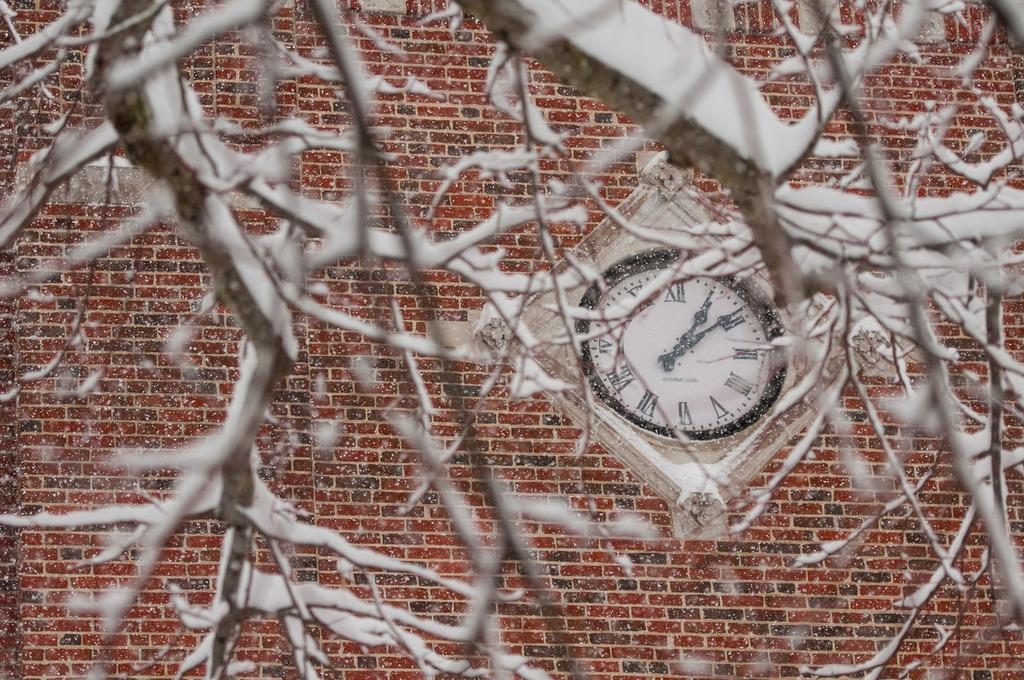What can be seen on the branches in the image? The branches in the image are empty. What is located in front of the branches? There is a wall in front of the branches. What object is positioned between the wall and the branches? There is a clock between the wall and the branches. What type of silver pear can be seen hanging from the ear in the image? There is no silver pear or ear present in the image. 